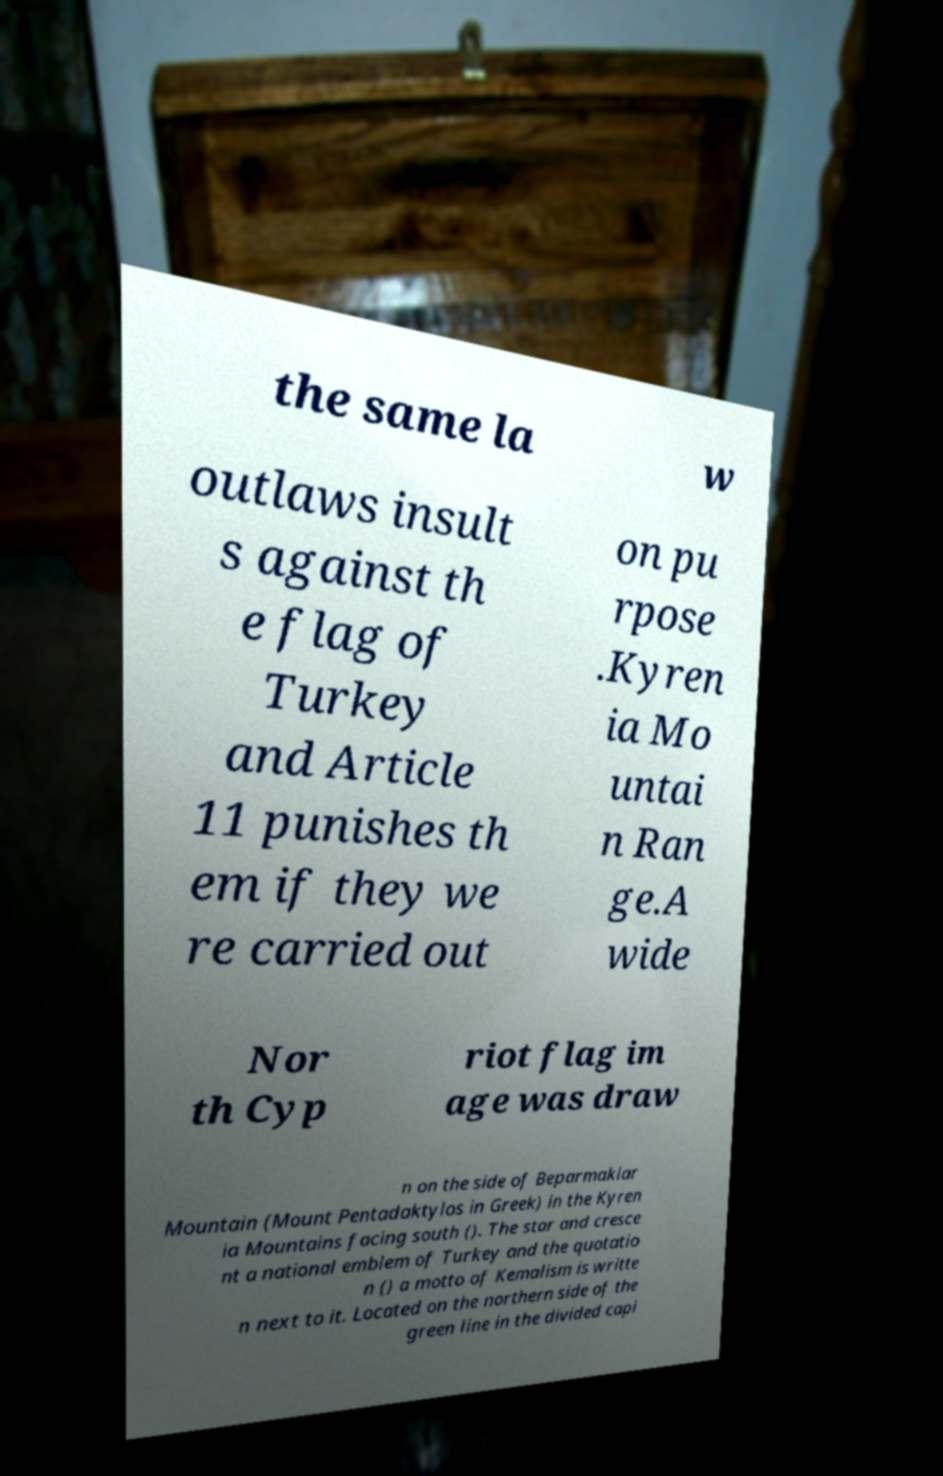Could you assist in decoding the text presented in this image and type it out clearly? the same la w outlaws insult s against th e flag of Turkey and Article 11 punishes th em if they we re carried out on pu rpose .Kyren ia Mo untai n Ran ge.A wide Nor th Cyp riot flag im age was draw n on the side of Beparmaklar Mountain (Mount Pentadaktylos in Greek) in the Kyren ia Mountains facing south (). The star and cresce nt a national emblem of Turkey and the quotatio n () a motto of Kemalism is writte n next to it. Located on the northern side of the green line in the divided capi 